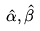Convert formula to latex. <formula><loc_0><loc_0><loc_500><loc_500>\hat { \alpha } , \hat { \beta }</formula> 